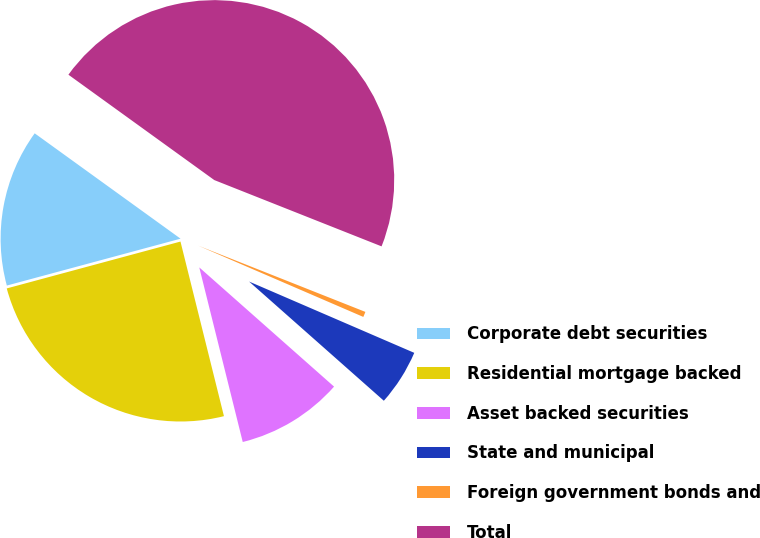Convert chart. <chart><loc_0><loc_0><loc_500><loc_500><pie_chart><fcel>Corporate debt securities<fcel>Residential mortgage backed<fcel>Asset backed securities<fcel>State and municipal<fcel>Foreign government bonds and<fcel>Total<nl><fcel>14.15%<fcel>24.69%<fcel>9.59%<fcel>5.04%<fcel>0.48%<fcel>46.05%<nl></chart> 